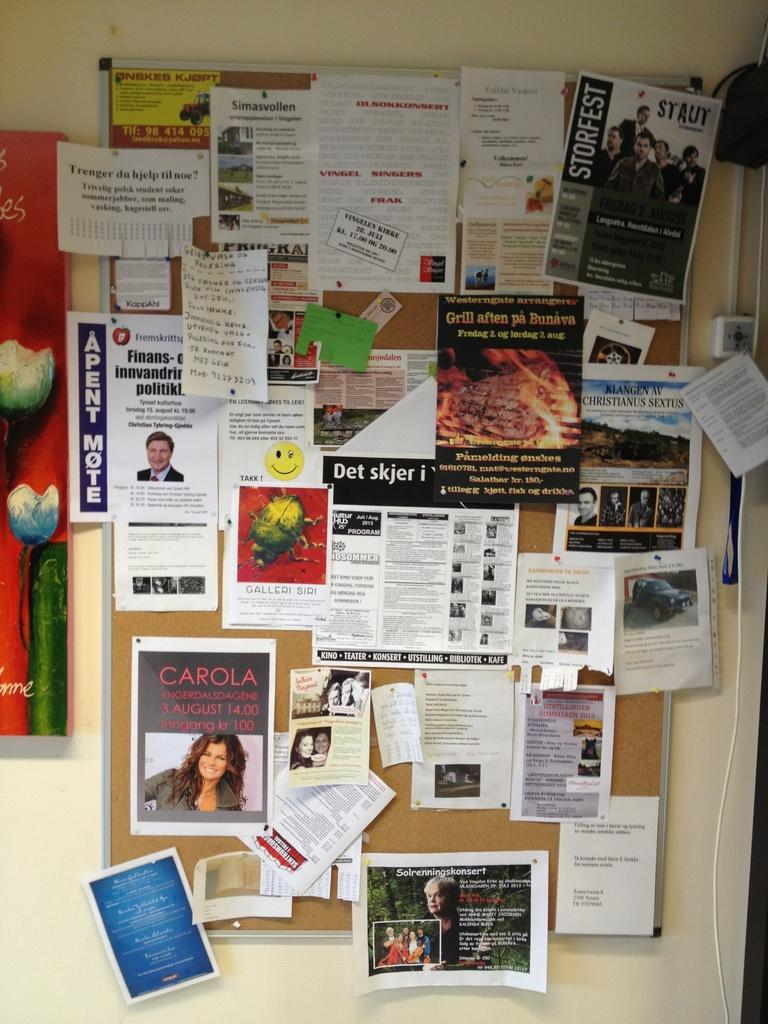What is the main object in the image? There is a notice board in the image. What is attached to the notice board? There are posters on the notice board. What can be seen in the background of the image? There is a wall in the background of the image. Where is the drawer located in the image? There is no drawer present in the image. What type of hospital is depicted in the image? There is no hospital depicted in the image. 